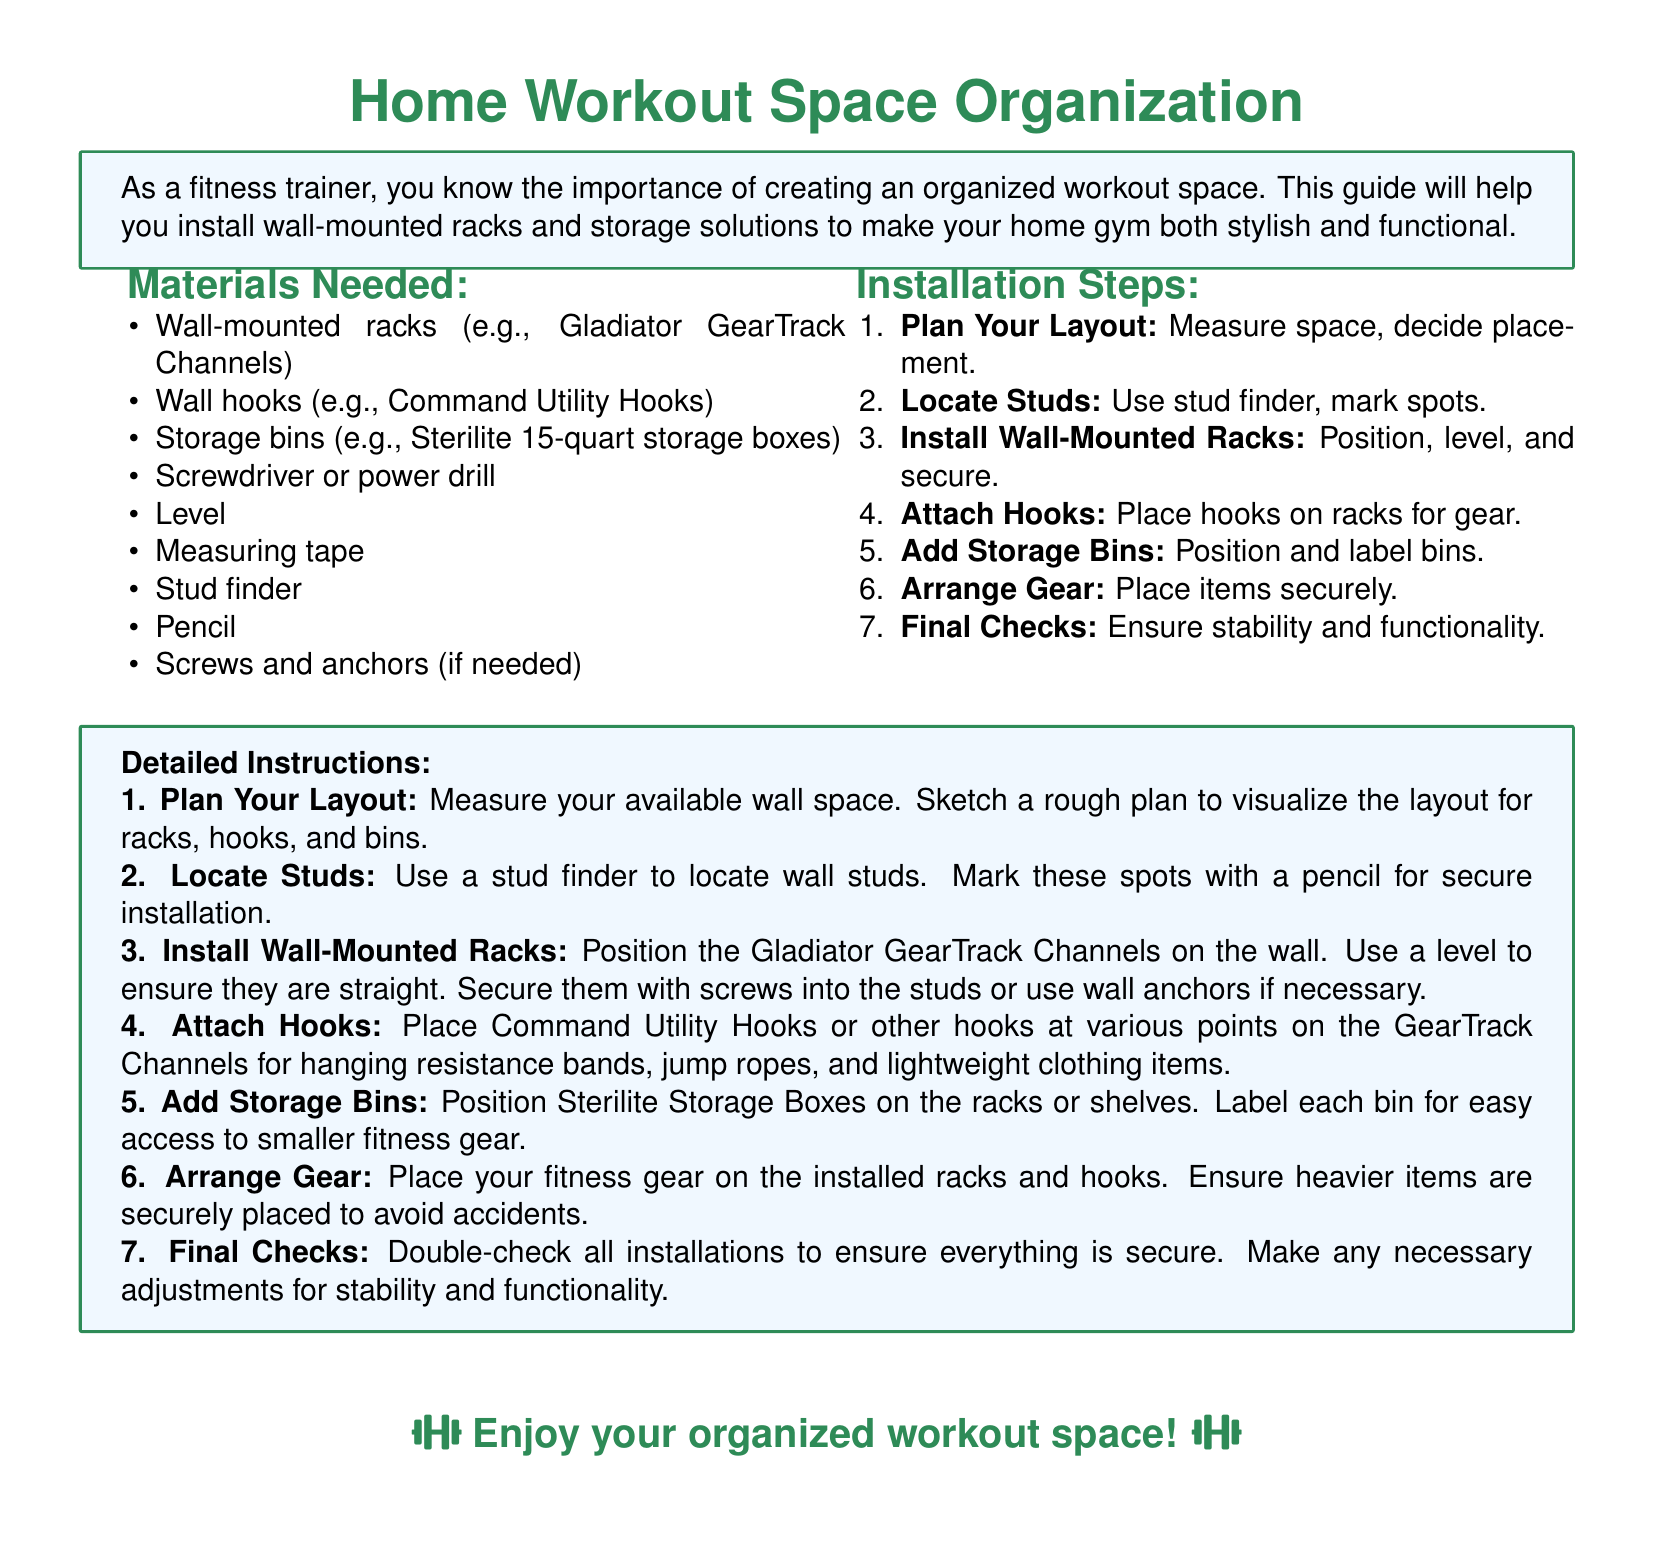What is the title of the document? The title of the document is prominently displayed at the top of the document in a large font.
Answer: Home Workout Space Organization What is the first item listed in the materials needed? The materials section enumerates various items required for installation, with the first item being the focus.
Answer: Wall-mounted racks How many installation steps are there? The installation steps are clearly numbered and totalled for easy reference.
Answer: Seven What type of storage boxes are recommended? The document specifies the type of storage solutions to use within the installation instructions.
Answer: Sterilite 15-quart storage boxes What tool is suggested for locating wall studs? The instructions mention a specific tool necessary for securely installing the racks.
Answer: Stud finder Which item should be secured first during installation? The steps outline the order of tasks, indicating which should be prioritized for secure installation.
Answer: Wall-mounted racks What is advised to ensure stability during the final checks? The final checks emphasize the importance of verifying secure installation for functionality.
Answer: Ensure stability and functionality What color is used for the title? The document presents the title in a specific color which can be classified as part of the design.
Answer: RGB (46,139,87) What does the final note encourage the reader to do? The last statement in the document pushes the reader towards a certain action relating to their space.
Answer: Enjoy your organized workout space! 